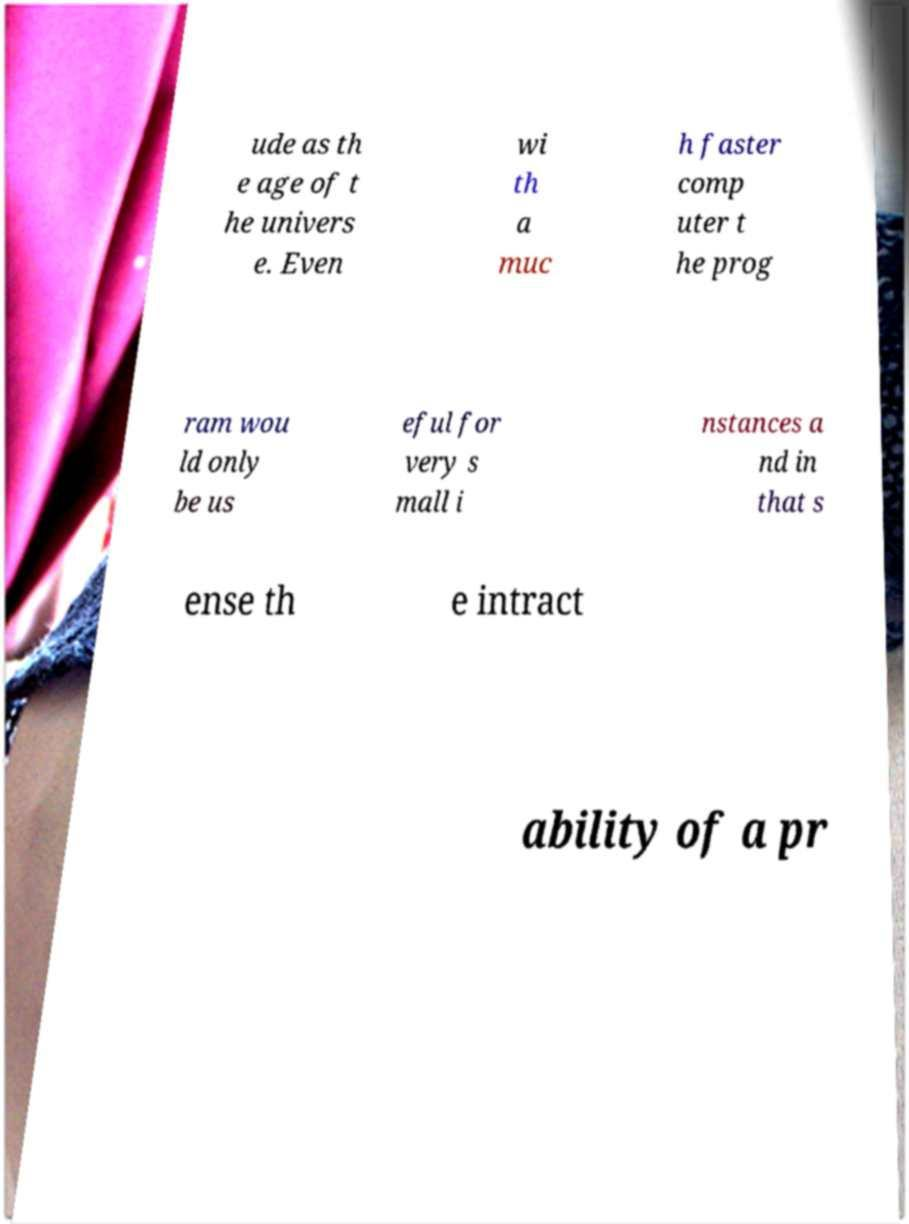I need the written content from this picture converted into text. Can you do that? ude as th e age of t he univers e. Even wi th a muc h faster comp uter t he prog ram wou ld only be us eful for very s mall i nstances a nd in that s ense th e intract ability of a pr 